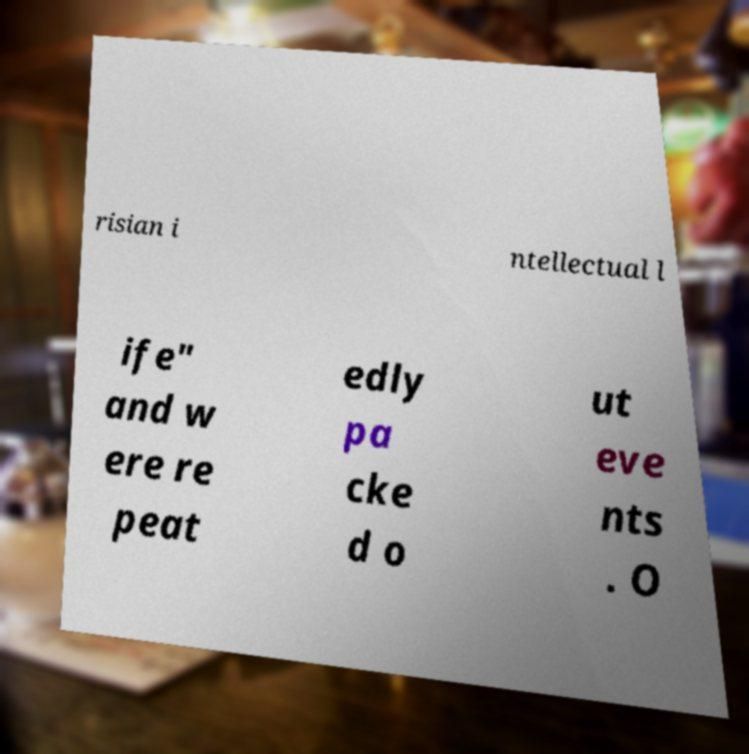For documentation purposes, I need the text within this image transcribed. Could you provide that? risian i ntellectual l ife" and w ere re peat edly pa cke d o ut eve nts . O 